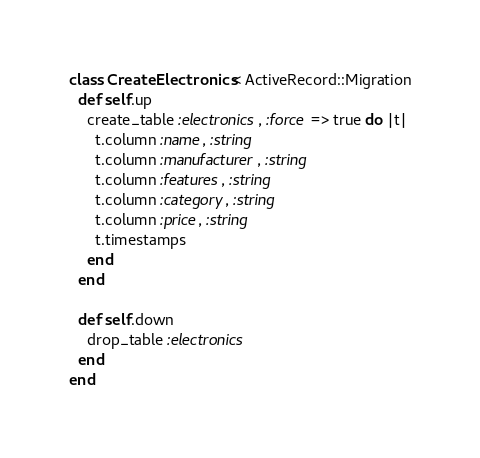<code> <loc_0><loc_0><loc_500><loc_500><_Ruby_>class CreateElectronics < ActiveRecord::Migration
  def self.up
    create_table :electronics, :force => true do |t|
      t.column :name, :string
      t.column :manufacturer, :string
      t.column :features, :string
      t.column :category, :string
      t.column :price, :string
      t.timestamps
    end
  end

  def self.down
    drop_table :electronics
  end
end
</code> 